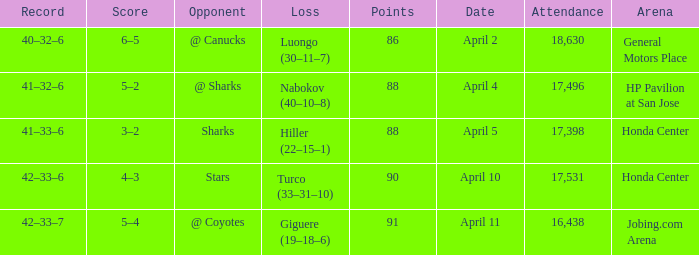Which Attendance has more than 90 points? 16438.0. 